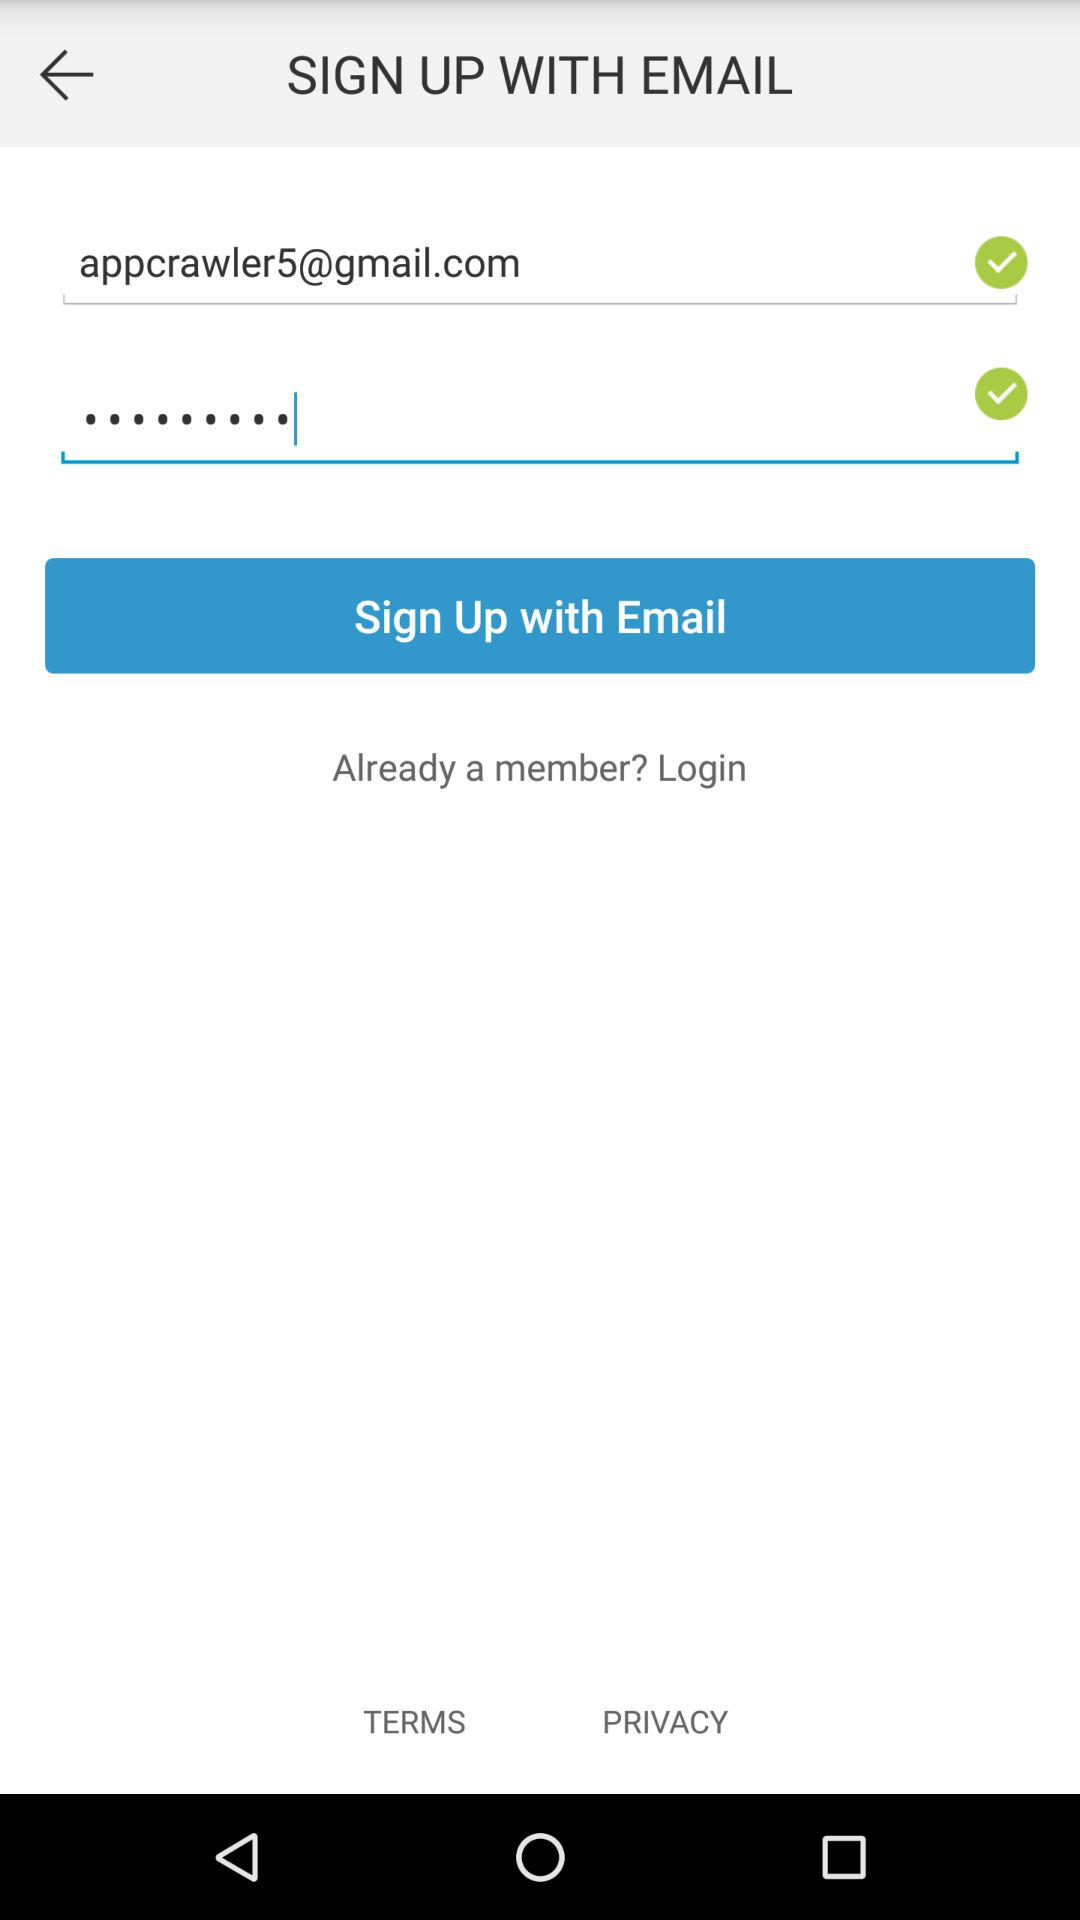How can we sign up? You can sign up with "EMAIL". 